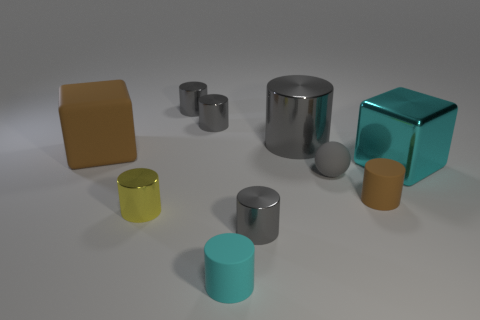Subtract all gray cylinders. How many were subtracted if there are2gray cylinders left? 2 Subtract all gray metallic cylinders. How many cylinders are left? 3 Subtract all brown blocks. How many blocks are left? 1 Subtract 4 cylinders. How many cylinders are left? 3 Add 2 big blue cylinders. How many big blue cylinders exist? 2 Subtract 0 purple balls. How many objects are left? 10 Subtract all cubes. How many objects are left? 8 Subtract all green cylinders. Subtract all blue blocks. How many cylinders are left? 7 Subtract all gray blocks. How many cyan cylinders are left? 1 Subtract all blocks. Subtract all green metal blocks. How many objects are left? 8 